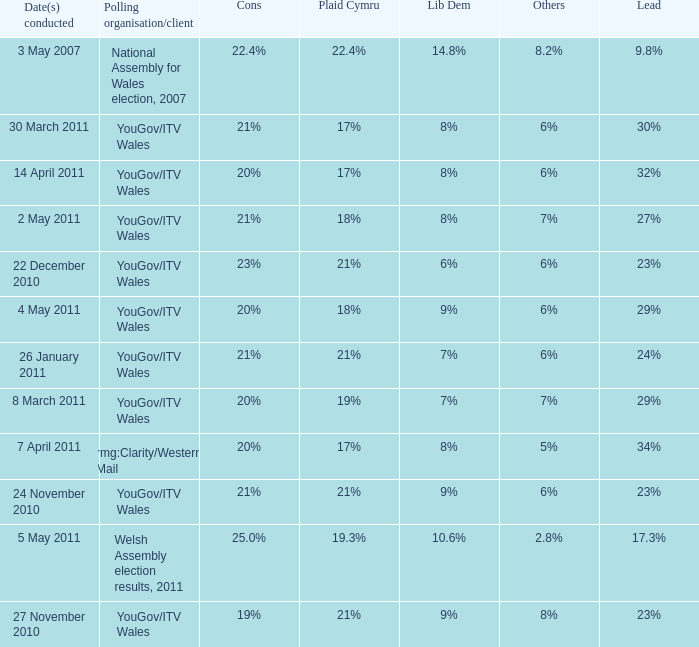I want the plaid cymru for 4 may 2011 18%. 